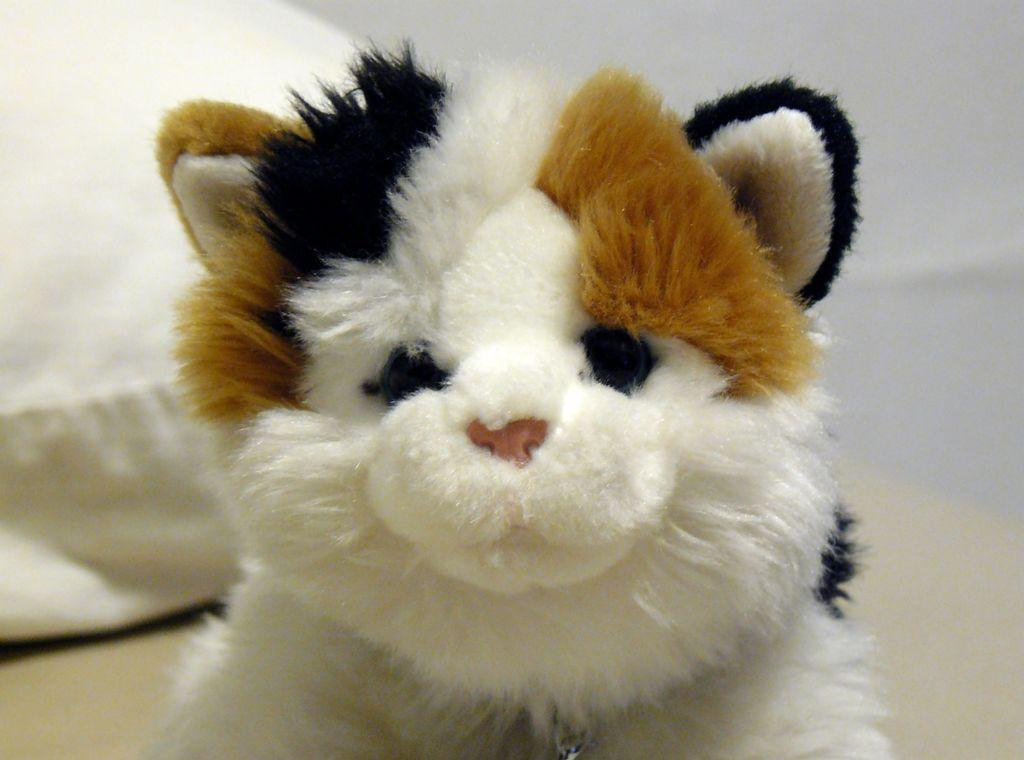What type of toy is present in the image? There is a toy dog in the image. Can you describe the background of the image? The background of the image is blurred. What object can be seen in the background of the image? There is a pillow in the background of the image. What action is the toy dog performing in the image? The toy dog is not performing any action in the image; it is a static object. What type of box is visible in the image? There is no box present in the image. 